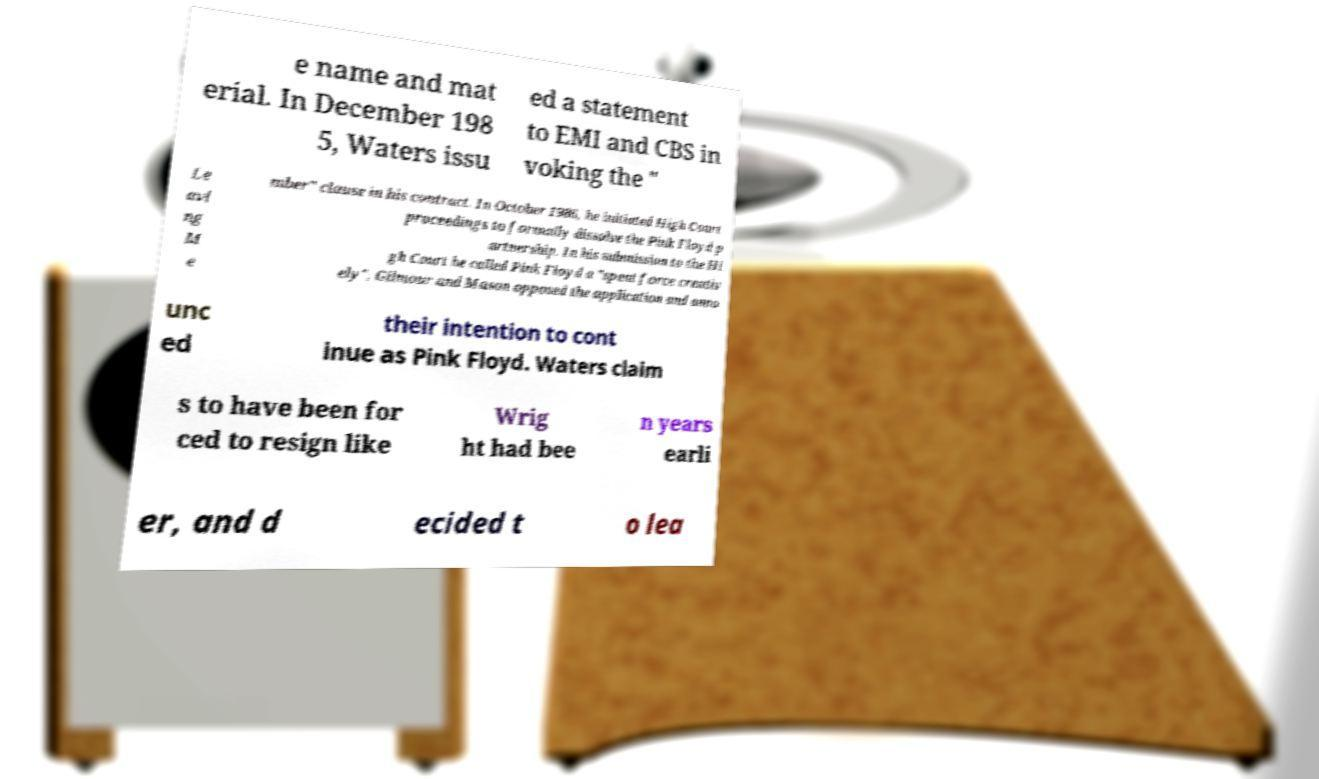Please read and relay the text visible in this image. What does it say? e name and mat erial. In December 198 5, Waters issu ed a statement to EMI and CBS in voking the " Le avi ng M e mber" clause in his contract. In October 1986, he initiated High Court proceedings to formally dissolve the Pink Floyd p artnership. In his submission to the Hi gh Court he called Pink Floyd a "spent force creativ ely". Gilmour and Mason opposed the application and anno unc ed their intention to cont inue as Pink Floyd. Waters claim s to have been for ced to resign like Wrig ht had bee n years earli er, and d ecided t o lea 